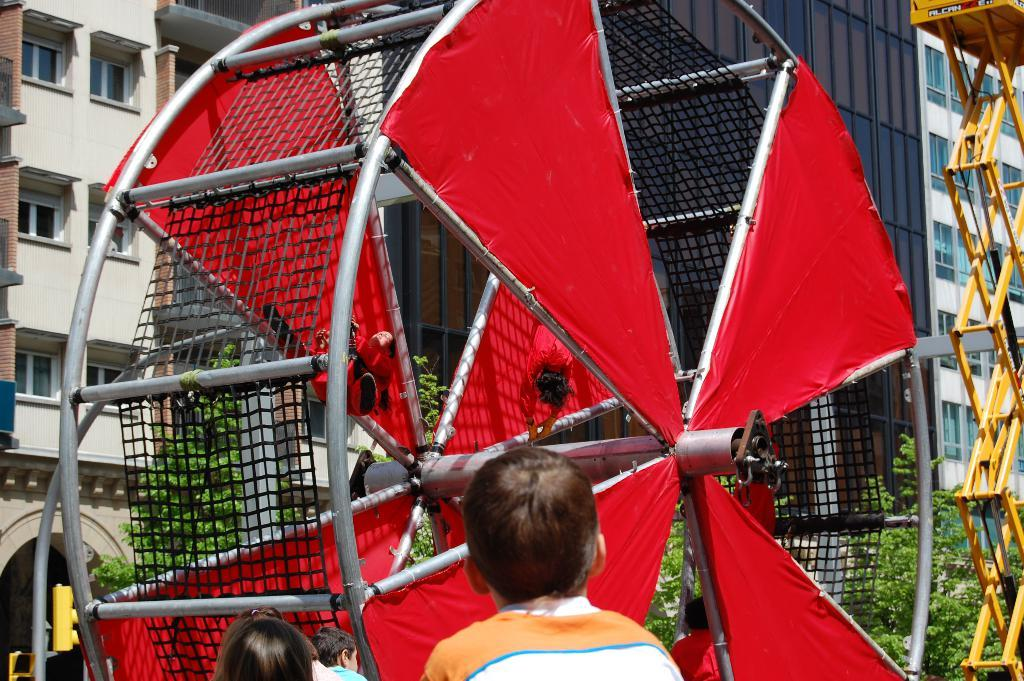What can be seen at the bottom of the image? There are kids standing at the bottom of the image. What are the kids doing in the image? The kids are watching something. What is in front of the kids? There are objects in front of the kids. What can be seen behind the objects? There are trees and buildings behind the objects. What else is visible in the image? There are poles visible in the image. What type of lumber is being used to build the face in the image? There is no face or lumber present in the image. 